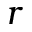Convert formula to latex. <formula><loc_0><loc_0><loc_500><loc_500>r</formula> 